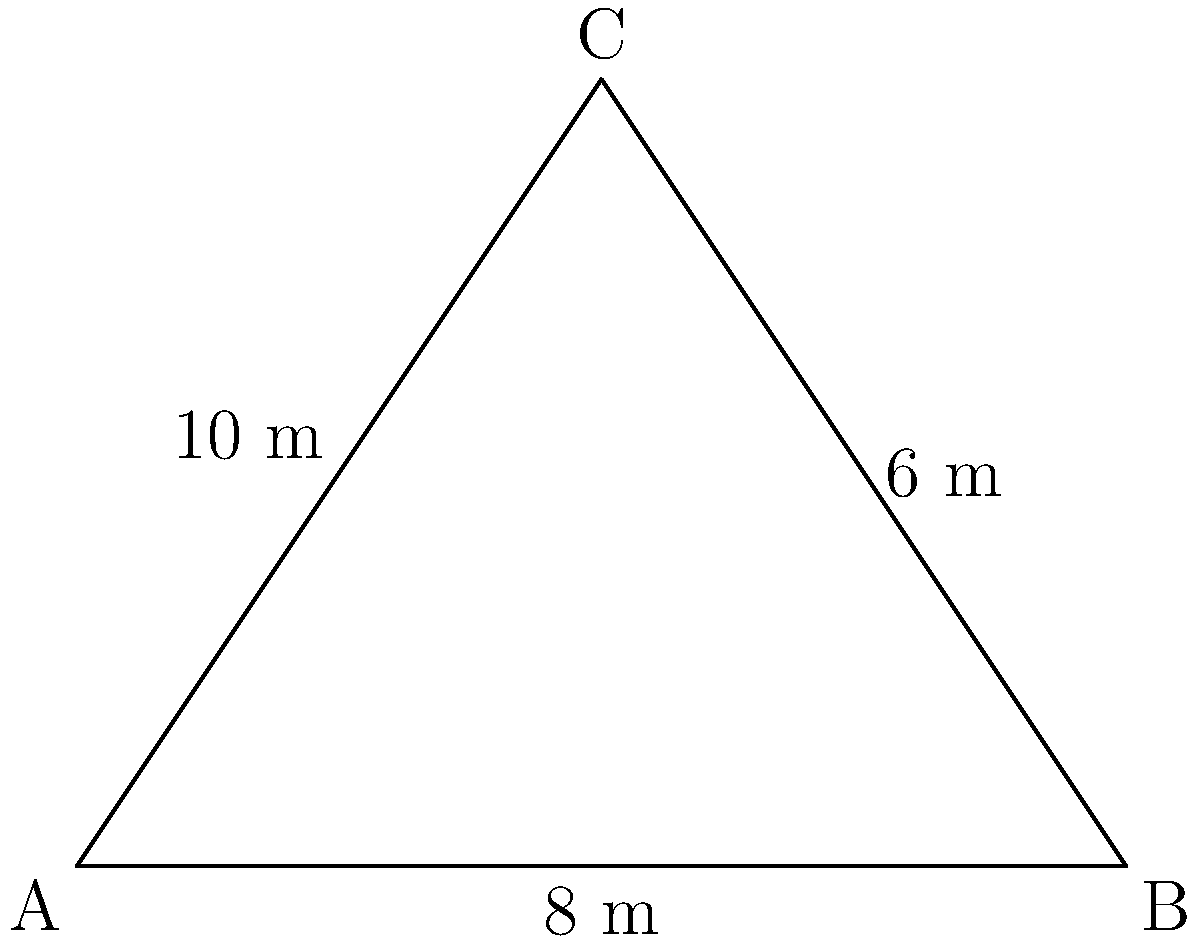For an upcoming event, you need to outline a triangular stage with decorative lighting. The stage has sides measuring 8 m, 10 m, and 6 m. How many meters of lighting strip will you need to completely outline the stage, allowing for an extra 10% for overlap and wastage? To solve this problem, we'll follow these steps:

1. Calculate the perimeter of the triangular stage:
   * Perimeter = sum of all sides
   * Perimeter = 8 m + 10 m + 6 m = 24 m

2. Add 10% for overlap and wastage:
   * Extra length = 10% of 24 m
   * Extra length = 0.10 × 24 m = 2.4 m

3. Calculate the total length needed:
   * Total length = Perimeter + Extra length
   * Total length = 24 m + 2.4 m = 26.4 m

Therefore, you will need 26.4 meters of lighting strip to outline the triangular stage, including the extra 10% for overlap and wastage.
Answer: 26.4 m 